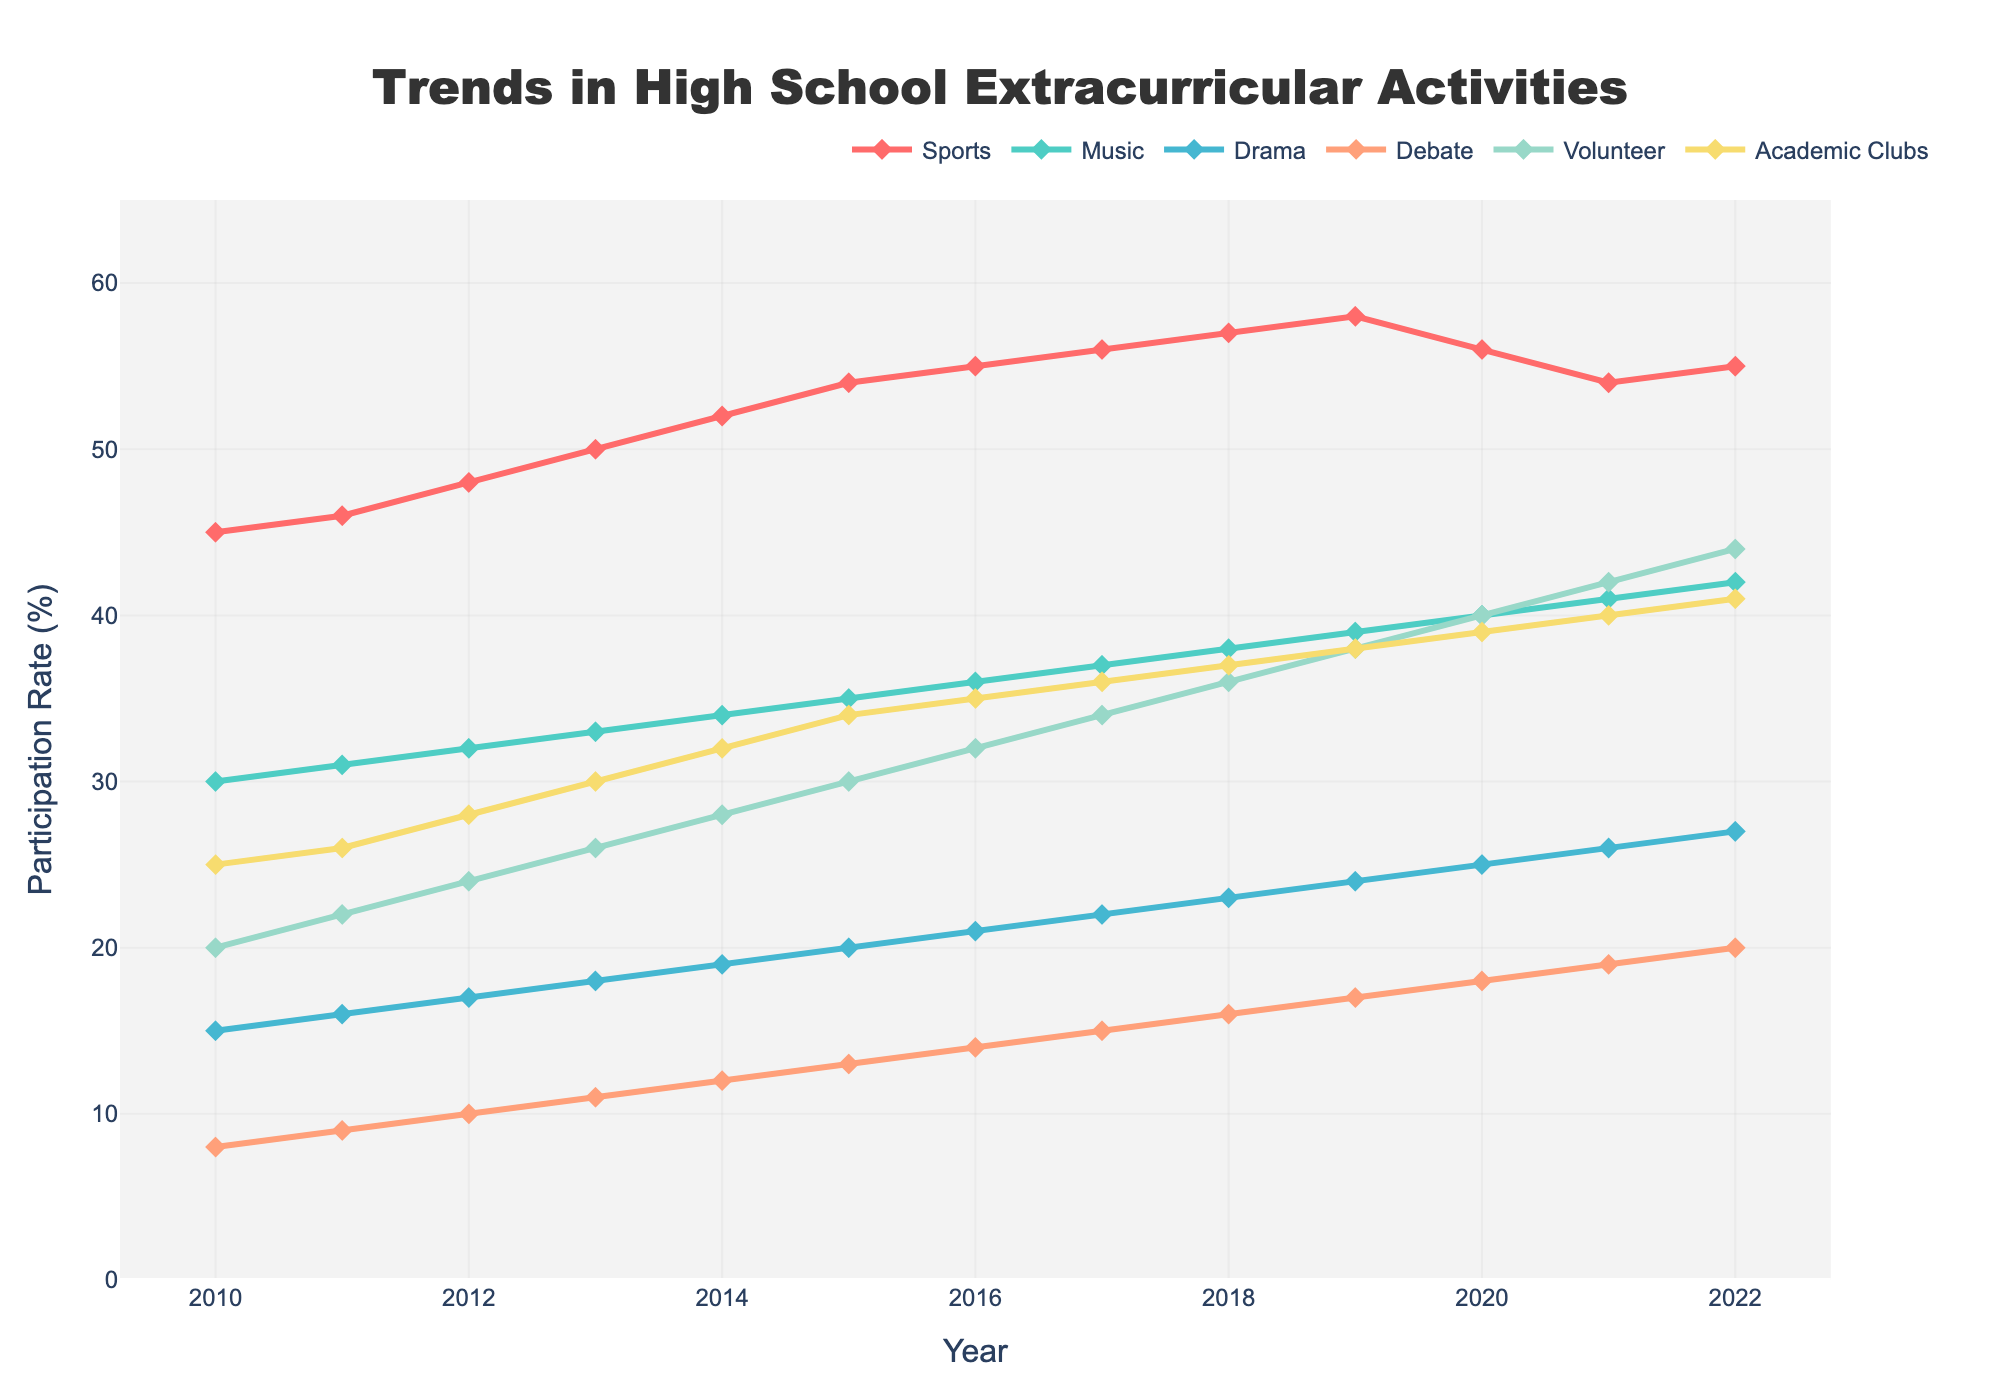what are the participation rates for sports in 2012 and 2022, and how much did they change? In the line chart, locate the participation rate for sports in 2012 (48%) and in 2022 (55%). Subtract the 2012 value from the 2022 value to find the change: 55% - 48% = 7%
Answer: 7% How does the participation in music compare between 2015 and 2020? Identify the values for music participation in 2015 (35%) and 2020 (40%). Compare them directly. Since 40% is greater than 35%, the participation increased.
Answer: Increased Which activity reached a participation rate of 40% first, and in which year? Look for the first occurrence of a 40% participation rate across all activities. Music reached 40% in 2020.
Answer: Music, 2020 By how much did academic clubs participation change from 2010 to 2022? Note the participation rates for academic clubs in 2010 (25%) and in 2022 (41%). Subtract the 2010 rate from the 2022 rate: 41% - 25% = 16%
Answer: 16% Which activity had the highest increase in participation rates from 2010 to 2022? Calculate the change for each activity from 2010 to 2022 by subtracting the 2010 participation rates from the 2022 rates. Sports: 55% - 45% = 10%, Music: 42% - 30% = 12%, Drama: 27% - 15% = 12%, Debate: 20% - 8% = 12%, Volunteer: 44% - 20% = 24%, Academic Clubs: 41% - 25% = 16%. The largest increase is in Volunteer at 24%
Answer: Volunteer Which year had the highest overall participation in all activities combined? Sum the participation rates across all activities for each year and compare to find the highest total. For example, for 2022, sum the values: 55 + 42 + 27 + 20 + 44 + 41 = 229%. The highest overall sum for any year is in 2022.
Answer: 2022 What visual trend can be observed for debate participation from 2010 to 2022? Trace the line for debate from 2010 to 2022. The visual trend shows a consistent increase in participation rates, marked by a positive slope in the graph.
Answer: Consistently increasing How does volunteer participation in 2017 compare to music participation in the same year? Identify the participation rates for volunteer (34%) and music (37%) in 2017 and compare them. Since 37% is greater than 34%, music has higher participation.
Answer: Music is higher What's the difference in participation rates between sports and academic clubs in 2013? Locate the participation rates for sports (50%) and academic clubs (30%) in 2013. Subtract the academic clubs value from the sports value: 50% - 30% = 20%
Answer: 20% By how much did drama participation increase from 2010 to 2019? Look at the drama participation rates for 2010 (15%) and 2019 (24%). Subtract the 2010 value from the 2019 value: 24% - 15% = 9%
Answer: 9% 